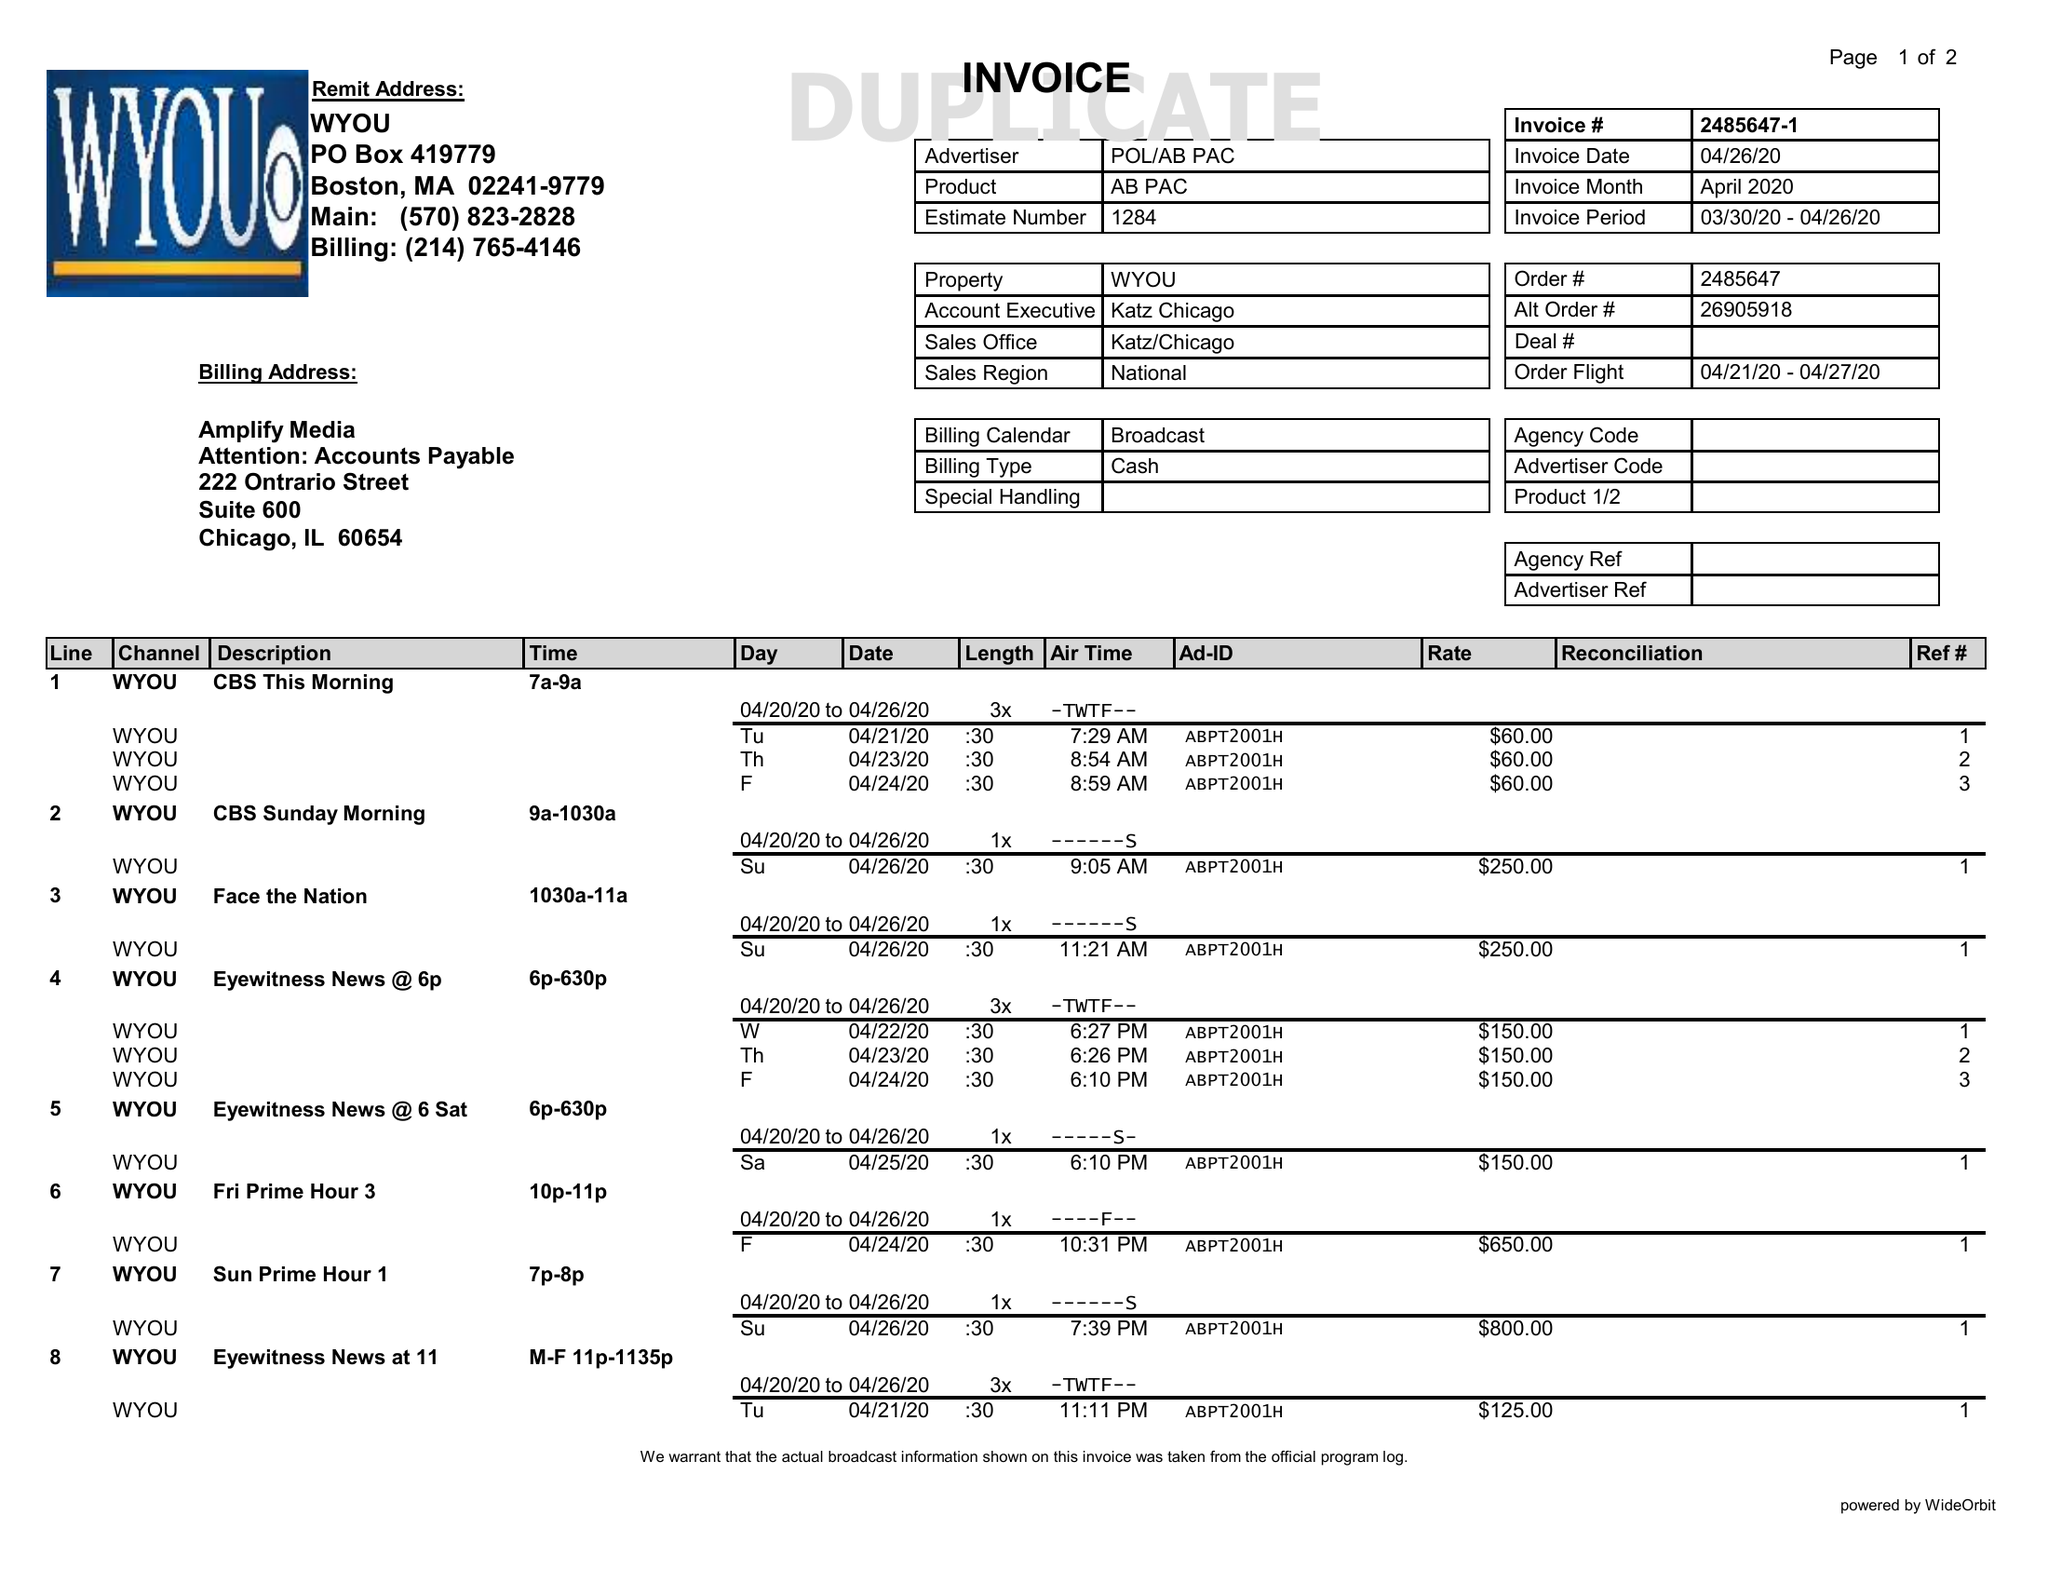What is the value for the gross_amount?
Answer the question using a single word or phrase. 3355.00 